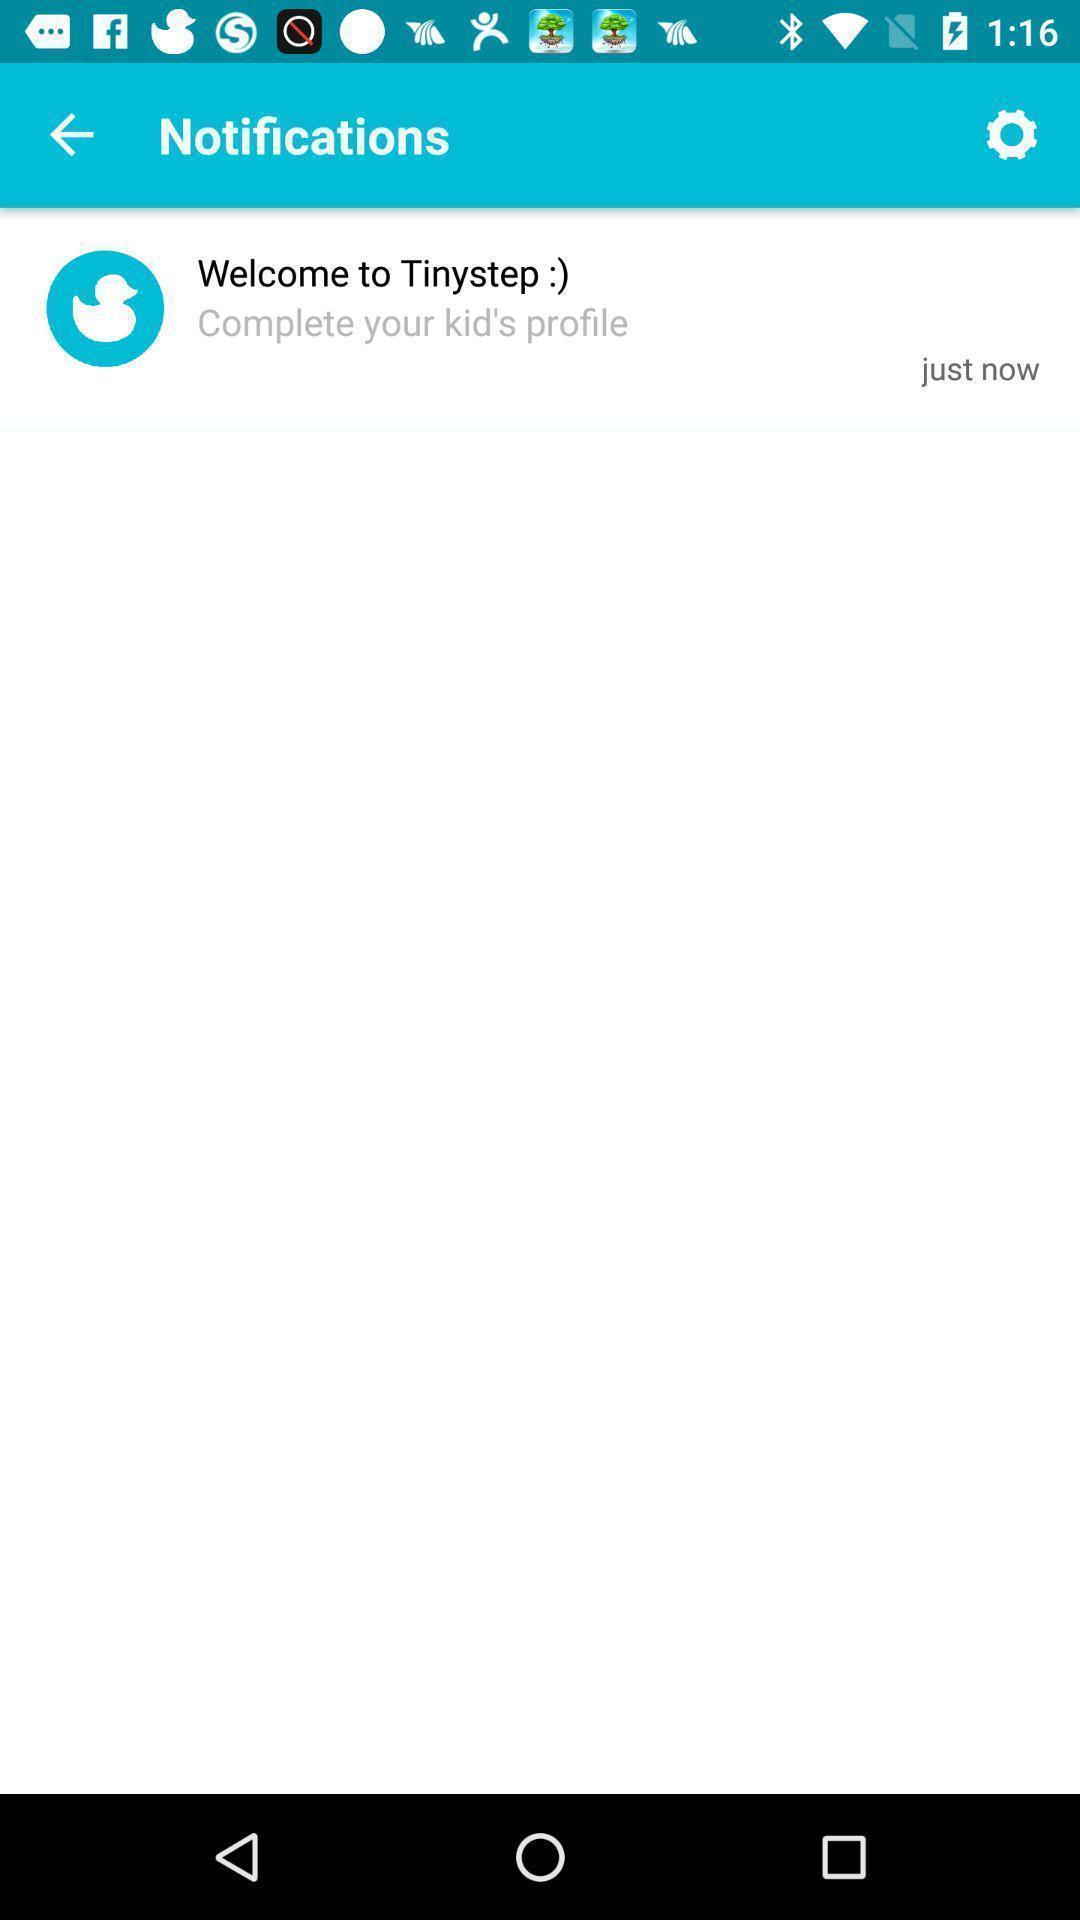Describe this image in words. Screen showing notifications. 